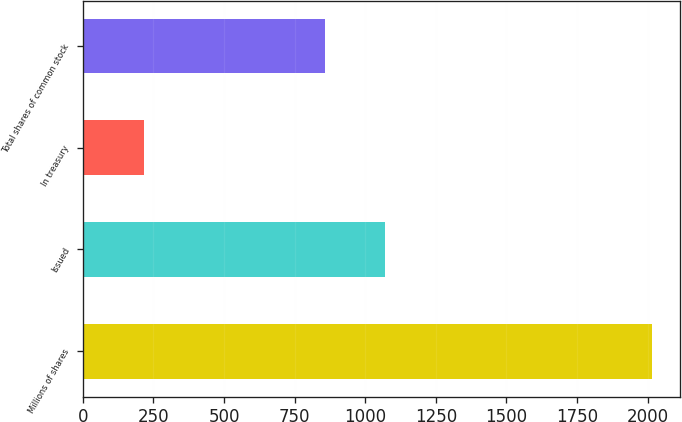<chart> <loc_0><loc_0><loc_500><loc_500><bar_chart><fcel>Millions of shares<fcel>Issued<fcel>In treasury<fcel>Total shares of common stock<nl><fcel>2015<fcel>1071<fcel>215<fcel>856<nl></chart> 